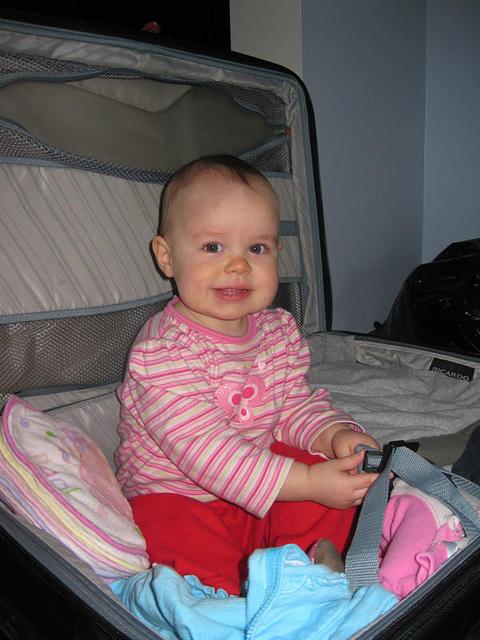Is the baby going to be packed too?
Concise answer only. No. Does this child have hair?
Concise answer only. Yes. Is the child in a car?
Answer briefly. No. What color shirt does the child have on?
Give a very brief answer. Pink. What color pants is the child wearing?
Keep it brief. Red. 